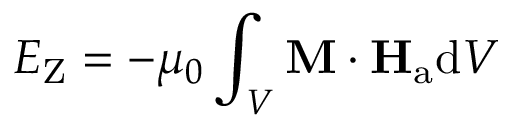<formula> <loc_0><loc_0><loc_500><loc_500>E _ { Z } = - \mu _ { 0 } \int _ { V } M \cdot H _ { a } d V</formula> 